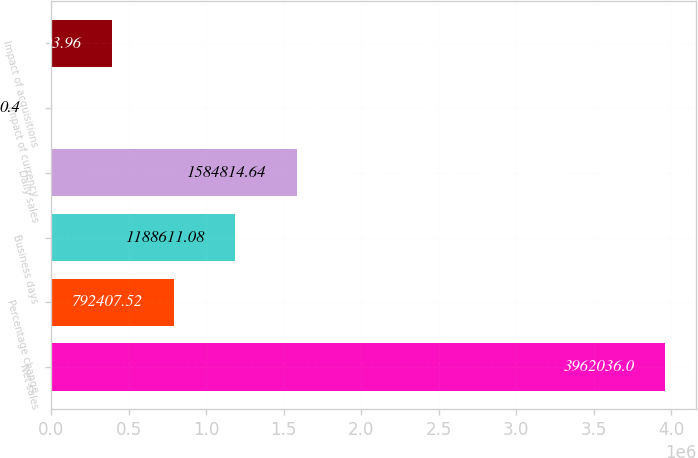Convert chart to OTSL. <chart><loc_0><loc_0><loc_500><loc_500><bar_chart><fcel>Net sales<fcel>Percentage change<fcel>Business days<fcel>Daily sales<fcel>Impact of currency<fcel>Impact of acquisitions<nl><fcel>3.96204e+06<fcel>792408<fcel>1.18861e+06<fcel>1.58481e+06<fcel>0.4<fcel>396204<nl></chart> 